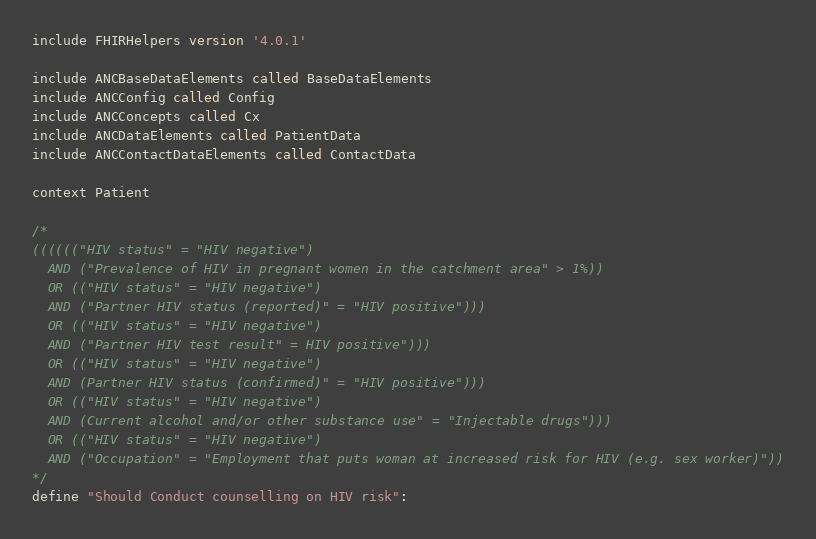Convert code to text. <code><loc_0><loc_0><loc_500><loc_500><_SQL_>include FHIRHelpers version '4.0.1'

include ANCBaseDataElements called BaseDataElements
include ANCConfig called Config
include ANCConcepts called Cx
include ANCDataElements called PatientData
include ANCContactDataElements called ContactData

context Patient

/*
(((((("HIV status" = "HIV negative")
  AND ("Prevalence of HIV in pregnant women in the catchment area" > 1%))
  OR (("HIV status" = "HIV negative")
  AND ("Partner HIV status (reported)" = "HIV positive")))
  OR (("HIV status" = "HIV negative")
  AND ("Partner HIV test result" = HIV positive")))
  OR (("HIV status" = "HIV negative")
  AND (Partner HIV status (confirmed)" = "HIV positive")))
  OR (("HIV status" = "HIV negative")
  AND (Current alcohol and/or other substance use" = "Injectable drugs")))
  OR (("HIV status" = "HIV negative")
  AND ("Occupation" = "Employment that puts woman at increased risk for HIV (e.g. sex worker)"))
*/
define "Should Conduct counselling on HIV risk":</code> 